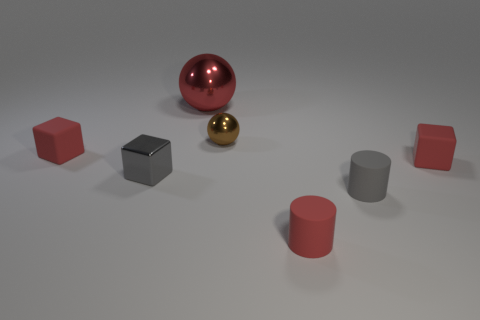Add 2 red objects. How many objects exist? 9 Subtract all cylinders. How many objects are left? 5 Subtract all tiny rubber blocks. Subtract all red cylinders. How many objects are left? 4 Add 4 small gray cubes. How many small gray cubes are left? 5 Add 4 gray metallic cubes. How many gray metallic cubes exist? 5 Subtract 1 brown spheres. How many objects are left? 6 